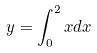<formula> <loc_0><loc_0><loc_500><loc_500>y = \int _ { 0 } ^ { 2 } x d x</formula> 